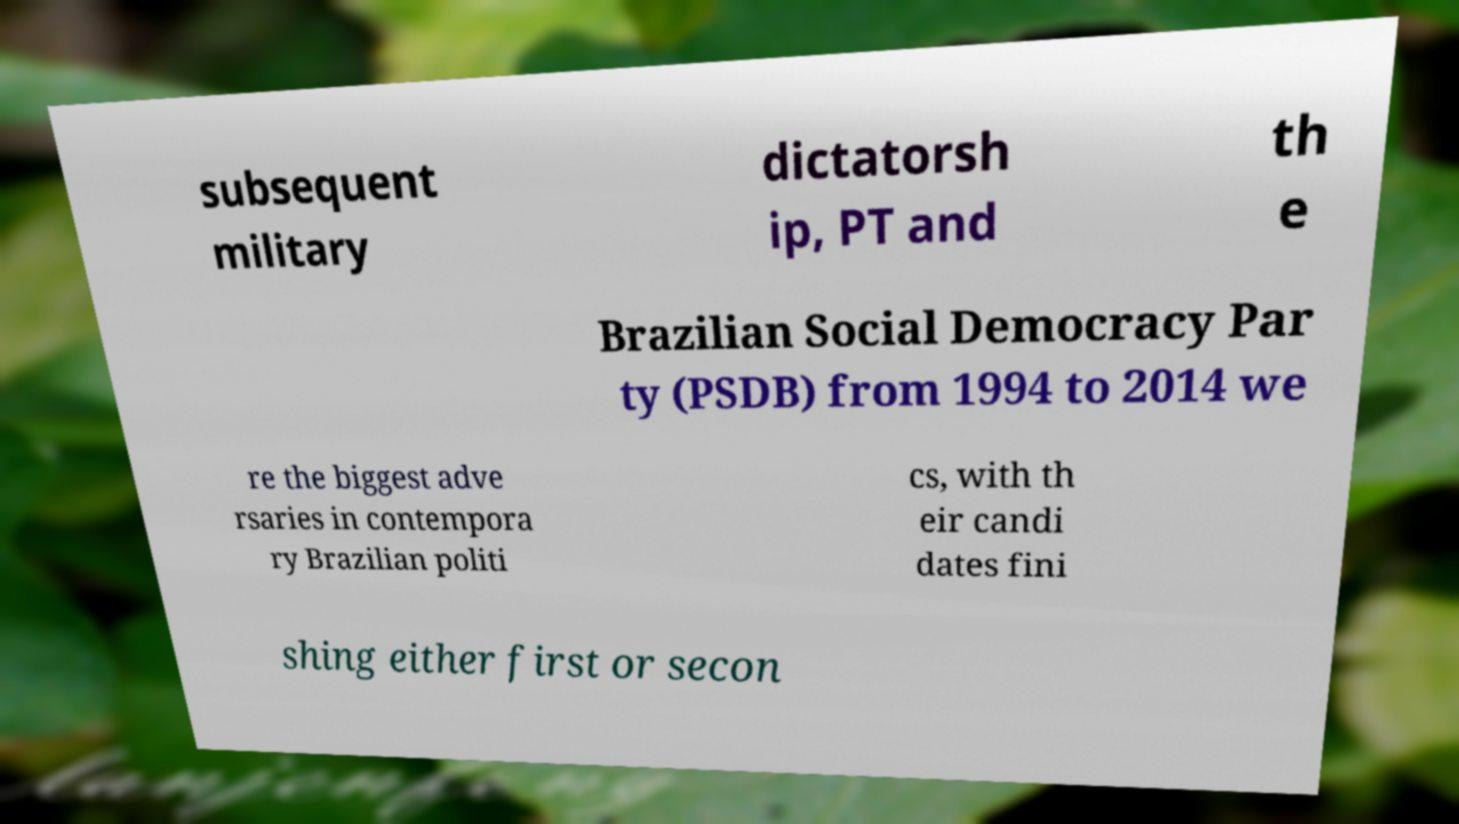Please identify and transcribe the text found in this image. subsequent military dictatorsh ip, PT and th e Brazilian Social Democracy Par ty (PSDB) from 1994 to 2014 we re the biggest adve rsaries in contempora ry Brazilian politi cs, with th eir candi dates fini shing either first or secon 